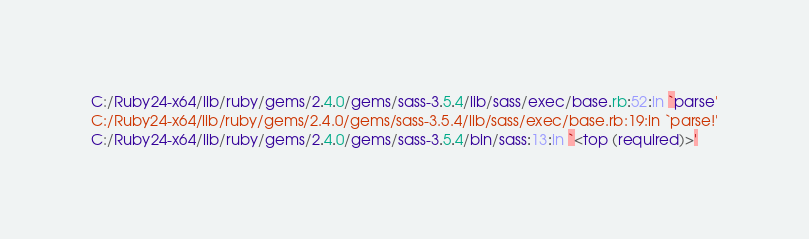<code> <loc_0><loc_0><loc_500><loc_500><_CSS_>C:/Ruby24-x64/lib/ruby/gems/2.4.0/gems/sass-3.5.4/lib/sass/exec/base.rb:52:in `parse'
C:/Ruby24-x64/lib/ruby/gems/2.4.0/gems/sass-3.5.4/lib/sass/exec/base.rb:19:in `parse!'
C:/Ruby24-x64/lib/ruby/gems/2.4.0/gems/sass-3.5.4/bin/sass:13:in `<top (required)>'</code> 